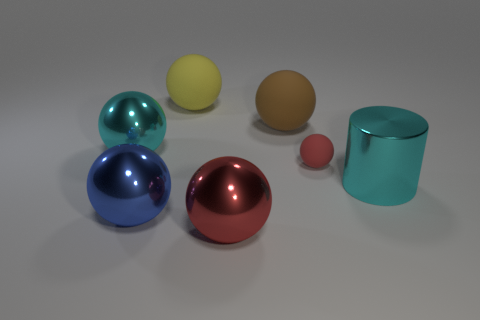Is the number of metallic objects that are right of the big blue metal thing greater than the number of rubber balls that are on the left side of the small rubber object?
Keep it short and to the point. No. Is there a large cyan cylinder?
Ensure brevity in your answer.  Yes. What material is the thing that is the same color as the large cylinder?
Your response must be concise. Metal. How many things are large red metallic balls or large cyan metal cylinders?
Provide a succinct answer. 2. Are there any large objects that have the same color as the small rubber sphere?
Give a very brief answer. Yes. What number of blue shiny objects are on the right side of the red object that is in front of the big shiny cylinder?
Provide a short and direct response. 0. Are there more blue metallic balls than cyan metal things?
Ensure brevity in your answer.  No. Is the material of the large blue sphere the same as the cyan cylinder?
Your answer should be very brief. Yes. Are there the same number of rubber spheres that are behind the big yellow object and big gray metallic cylinders?
Make the answer very short. Yes. How many large yellow objects have the same material as the brown thing?
Keep it short and to the point. 1. 